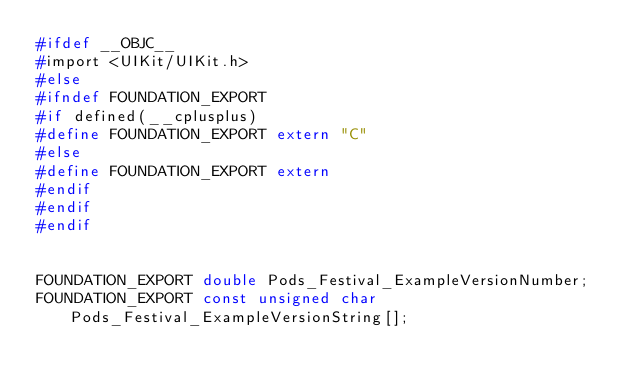<code> <loc_0><loc_0><loc_500><loc_500><_C_>#ifdef __OBJC__
#import <UIKit/UIKit.h>
#else
#ifndef FOUNDATION_EXPORT
#if defined(__cplusplus)
#define FOUNDATION_EXPORT extern "C"
#else
#define FOUNDATION_EXPORT extern
#endif
#endif
#endif


FOUNDATION_EXPORT double Pods_Festival_ExampleVersionNumber;
FOUNDATION_EXPORT const unsigned char Pods_Festival_ExampleVersionString[];

</code> 